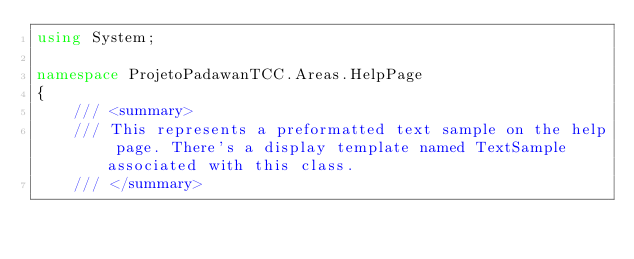Convert code to text. <code><loc_0><loc_0><loc_500><loc_500><_C#_>using System;

namespace ProjetoPadawanTCC.Areas.HelpPage
{
    /// <summary>
    /// This represents a preformatted text sample on the help page. There's a display template named TextSample associated with this class.
    /// </summary></code> 